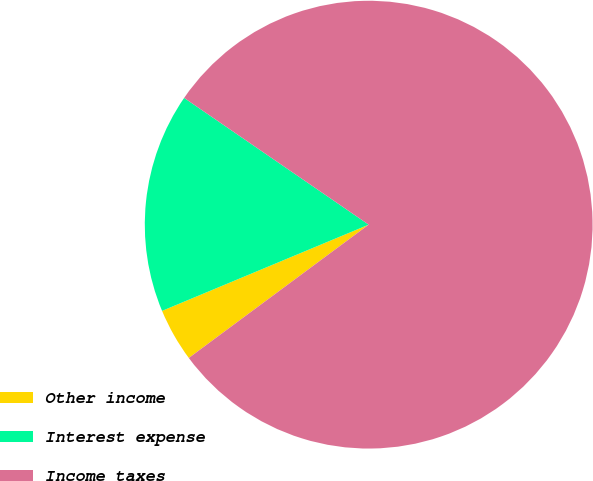Convert chart. <chart><loc_0><loc_0><loc_500><loc_500><pie_chart><fcel>Other income<fcel>Interest expense<fcel>Income taxes<nl><fcel>3.86%<fcel>15.87%<fcel>80.27%<nl></chart> 